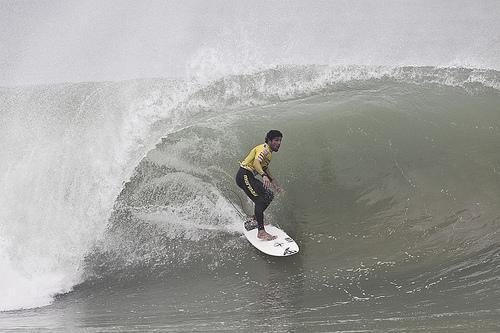How many people are in the photo?
Give a very brief answer. 1. 